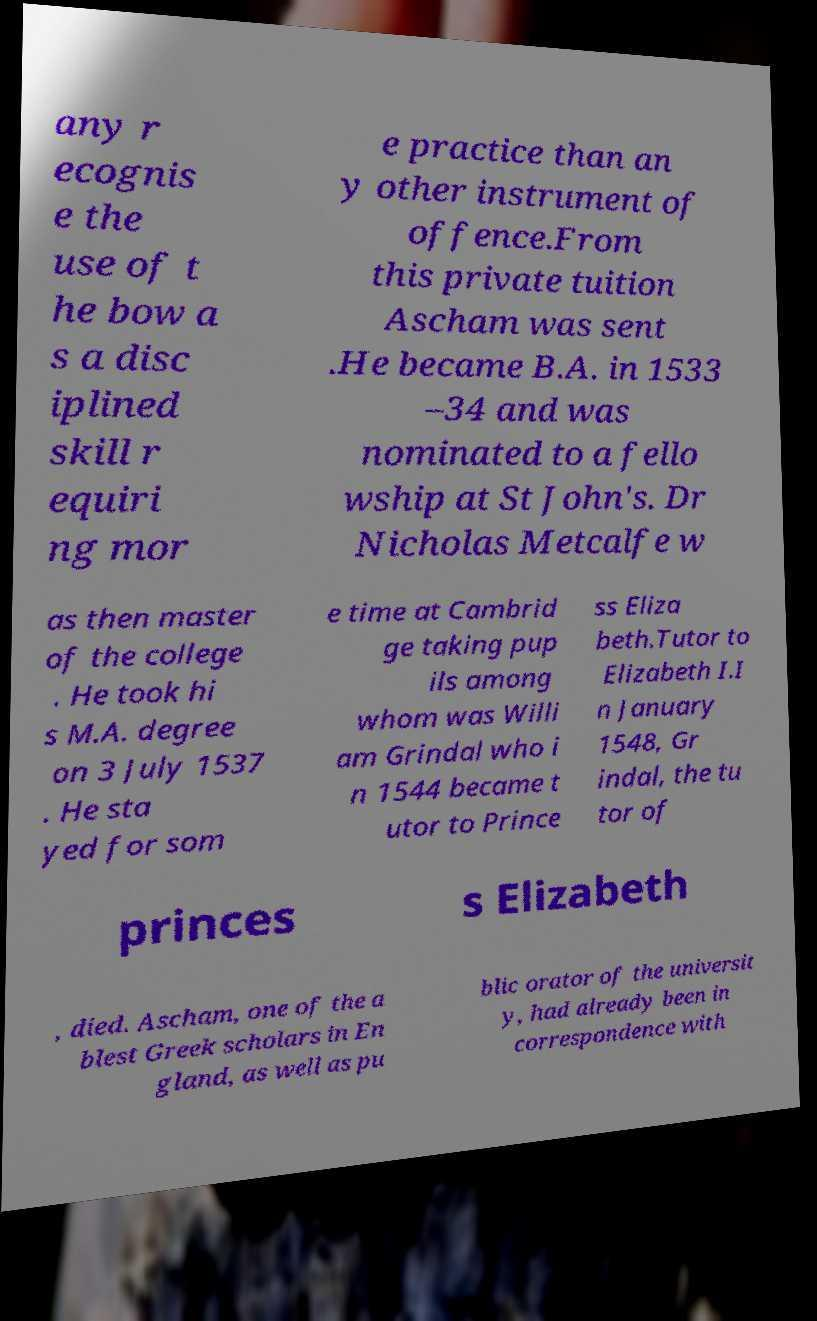Could you extract and type out the text from this image? any r ecognis e the use of t he bow a s a disc iplined skill r equiri ng mor e practice than an y other instrument of offence.From this private tuition Ascham was sent .He became B.A. in 1533 –34 and was nominated to a fello wship at St John's. Dr Nicholas Metcalfe w as then master of the college . He took hi s M.A. degree on 3 July 1537 . He sta yed for som e time at Cambrid ge taking pup ils among whom was Willi am Grindal who i n 1544 became t utor to Prince ss Eliza beth.Tutor to Elizabeth I.I n January 1548, Gr indal, the tu tor of princes s Elizabeth , died. Ascham, one of the a blest Greek scholars in En gland, as well as pu blic orator of the universit y, had already been in correspondence with 